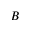<formula> <loc_0><loc_0><loc_500><loc_500>B</formula> 